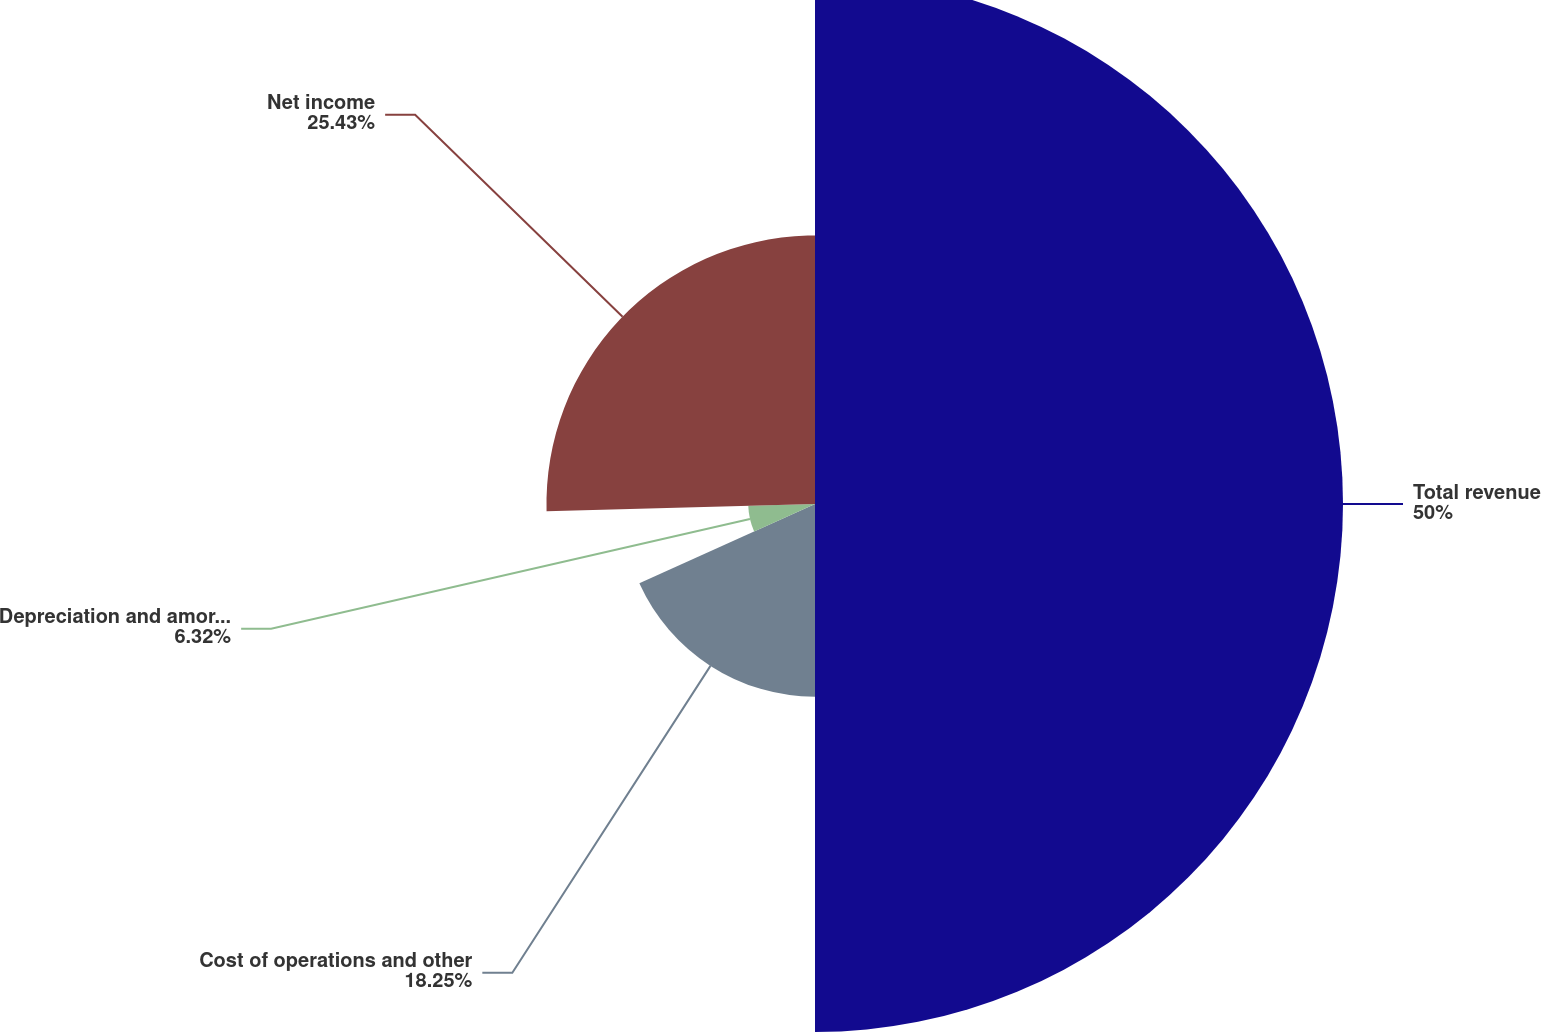Convert chart to OTSL. <chart><loc_0><loc_0><loc_500><loc_500><pie_chart><fcel>Total revenue<fcel>Cost of operations and other<fcel>Depreciation and amortization<fcel>Net income<nl><fcel>50.0%<fcel>18.25%<fcel>6.32%<fcel>25.43%<nl></chart> 